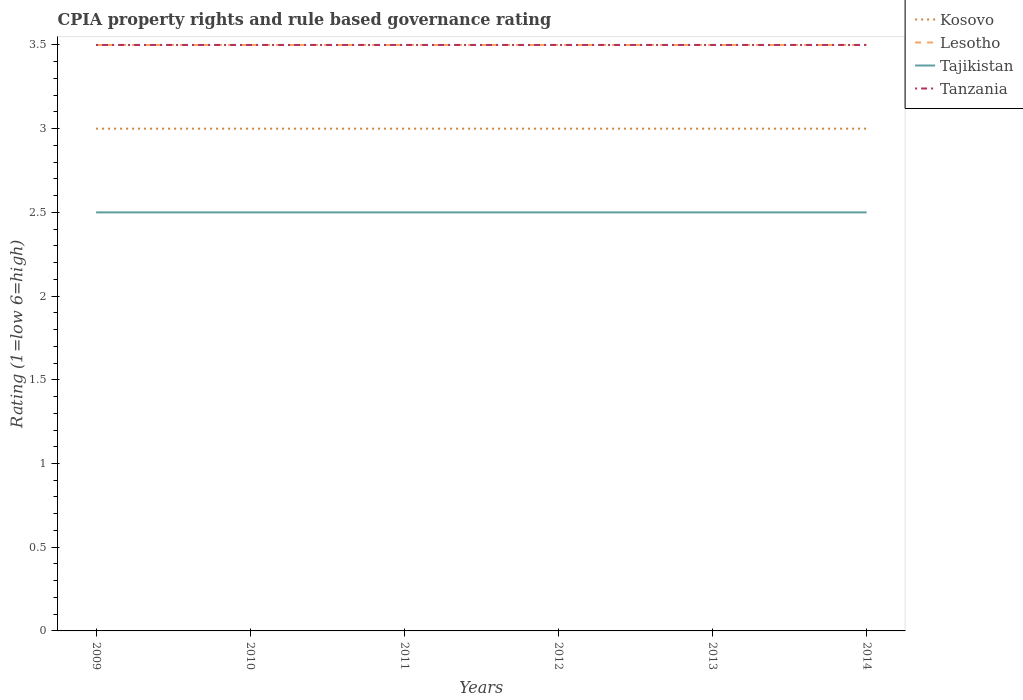Is the CPIA rating in Tajikistan strictly greater than the CPIA rating in Tanzania over the years?
Give a very brief answer. Yes. How many years are there in the graph?
Your response must be concise. 6. What is the difference between two consecutive major ticks on the Y-axis?
Your answer should be very brief. 0.5. Where does the legend appear in the graph?
Provide a succinct answer. Top right. What is the title of the graph?
Your answer should be compact. CPIA property rights and rule based governance rating. Does "Dominica" appear as one of the legend labels in the graph?
Give a very brief answer. No. What is the label or title of the Y-axis?
Make the answer very short. Rating (1=low 6=high). What is the Rating (1=low 6=high) of Kosovo in 2009?
Ensure brevity in your answer.  3. What is the Rating (1=low 6=high) of Lesotho in 2009?
Offer a terse response. 3.5. What is the Rating (1=low 6=high) of Tajikistan in 2010?
Keep it short and to the point. 2.5. What is the Rating (1=low 6=high) in Lesotho in 2011?
Provide a short and direct response. 3.5. What is the Rating (1=low 6=high) in Lesotho in 2012?
Keep it short and to the point. 3.5. What is the Rating (1=low 6=high) in Tajikistan in 2012?
Keep it short and to the point. 2.5. What is the Rating (1=low 6=high) in Tanzania in 2012?
Give a very brief answer. 3.5. What is the Rating (1=low 6=high) of Kosovo in 2013?
Give a very brief answer. 3. What is the Rating (1=low 6=high) of Tajikistan in 2013?
Keep it short and to the point. 2.5. What is the Rating (1=low 6=high) in Lesotho in 2014?
Give a very brief answer. 3.5. Across all years, what is the maximum Rating (1=low 6=high) of Kosovo?
Provide a short and direct response. 3. Across all years, what is the maximum Rating (1=low 6=high) in Tanzania?
Offer a very short reply. 3.5. Across all years, what is the minimum Rating (1=low 6=high) of Tanzania?
Offer a very short reply. 3.5. What is the total Rating (1=low 6=high) in Kosovo in the graph?
Ensure brevity in your answer.  18. What is the total Rating (1=low 6=high) of Tajikistan in the graph?
Your response must be concise. 15. What is the total Rating (1=low 6=high) in Tanzania in the graph?
Provide a succinct answer. 21. What is the difference between the Rating (1=low 6=high) in Kosovo in 2009 and that in 2010?
Provide a succinct answer. 0. What is the difference between the Rating (1=low 6=high) in Lesotho in 2009 and that in 2010?
Provide a short and direct response. 0. What is the difference between the Rating (1=low 6=high) in Kosovo in 2009 and that in 2011?
Provide a short and direct response. 0. What is the difference between the Rating (1=low 6=high) in Tajikistan in 2009 and that in 2011?
Your answer should be compact. 0. What is the difference between the Rating (1=low 6=high) of Kosovo in 2009 and that in 2012?
Your response must be concise. 0. What is the difference between the Rating (1=low 6=high) in Kosovo in 2009 and that in 2013?
Provide a short and direct response. 0. What is the difference between the Rating (1=low 6=high) in Lesotho in 2009 and that in 2013?
Keep it short and to the point. 0. What is the difference between the Rating (1=low 6=high) of Tanzania in 2009 and that in 2013?
Your response must be concise. 0. What is the difference between the Rating (1=low 6=high) of Lesotho in 2009 and that in 2014?
Ensure brevity in your answer.  0. What is the difference between the Rating (1=low 6=high) of Tanzania in 2009 and that in 2014?
Make the answer very short. 0. What is the difference between the Rating (1=low 6=high) in Kosovo in 2010 and that in 2011?
Give a very brief answer. 0. What is the difference between the Rating (1=low 6=high) of Lesotho in 2010 and that in 2011?
Provide a short and direct response. 0. What is the difference between the Rating (1=low 6=high) of Tanzania in 2010 and that in 2011?
Make the answer very short. 0. What is the difference between the Rating (1=low 6=high) of Kosovo in 2010 and that in 2012?
Offer a terse response. 0. What is the difference between the Rating (1=low 6=high) of Lesotho in 2010 and that in 2012?
Make the answer very short. 0. What is the difference between the Rating (1=low 6=high) of Kosovo in 2010 and that in 2013?
Provide a short and direct response. 0. What is the difference between the Rating (1=low 6=high) of Lesotho in 2010 and that in 2013?
Offer a terse response. 0. What is the difference between the Rating (1=low 6=high) of Tanzania in 2010 and that in 2013?
Your response must be concise. 0. What is the difference between the Rating (1=low 6=high) in Kosovo in 2010 and that in 2014?
Your response must be concise. 0. What is the difference between the Rating (1=low 6=high) in Kosovo in 2011 and that in 2012?
Offer a terse response. 0. What is the difference between the Rating (1=low 6=high) of Kosovo in 2011 and that in 2013?
Keep it short and to the point. 0. What is the difference between the Rating (1=low 6=high) of Tajikistan in 2011 and that in 2013?
Your response must be concise. 0. What is the difference between the Rating (1=low 6=high) in Tanzania in 2011 and that in 2013?
Keep it short and to the point. 0. What is the difference between the Rating (1=low 6=high) of Tajikistan in 2011 and that in 2014?
Keep it short and to the point. 0. What is the difference between the Rating (1=low 6=high) in Tanzania in 2011 and that in 2014?
Give a very brief answer. 0. What is the difference between the Rating (1=low 6=high) of Lesotho in 2012 and that in 2013?
Offer a terse response. 0. What is the difference between the Rating (1=low 6=high) of Kosovo in 2012 and that in 2014?
Your response must be concise. 0. What is the difference between the Rating (1=low 6=high) of Tanzania in 2012 and that in 2014?
Ensure brevity in your answer.  0. What is the difference between the Rating (1=low 6=high) of Lesotho in 2013 and that in 2014?
Provide a succinct answer. 0. What is the difference between the Rating (1=low 6=high) of Kosovo in 2009 and the Rating (1=low 6=high) of Lesotho in 2010?
Your response must be concise. -0.5. What is the difference between the Rating (1=low 6=high) of Tajikistan in 2009 and the Rating (1=low 6=high) of Tanzania in 2010?
Make the answer very short. -1. What is the difference between the Rating (1=low 6=high) of Kosovo in 2009 and the Rating (1=low 6=high) of Tajikistan in 2011?
Offer a very short reply. 0.5. What is the difference between the Rating (1=low 6=high) in Kosovo in 2009 and the Rating (1=low 6=high) in Tanzania in 2011?
Ensure brevity in your answer.  -0.5. What is the difference between the Rating (1=low 6=high) in Lesotho in 2009 and the Rating (1=low 6=high) in Tajikistan in 2011?
Give a very brief answer. 1. What is the difference between the Rating (1=low 6=high) in Tajikistan in 2009 and the Rating (1=low 6=high) in Tanzania in 2011?
Ensure brevity in your answer.  -1. What is the difference between the Rating (1=low 6=high) of Tajikistan in 2009 and the Rating (1=low 6=high) of Tanzania in 2012?
Ensure brevity in your answer.  -1. What is the difference between the Rating (1=low 6=high) in Kosovo in 2009 and the Rating (1=low 6=high) in Lesotho in 2013?
Give a very brief answer. -0.5. What is the difference between the Rating (1=low 6=high) in Kosovo in 2009 and the Rating (1=low 6=high) in Tajikistan in 2013?
Offer a very short reply. 0.5. What is the difference between the Rating (1=low 6=high) of Tajikistan in 2009 and the Rating (1=low 6=high) of Tanzania in 2013?
Offer a very short reply. -1. What is the difference between the Rating (1=low 6=high) of Kosovo in 2009 and the Rating (1=low 6=high) of Lesotho in 2014?
Provide a succinct answer. -0.5. What is the difference between the Rating (1=low 6=high) of Kosovo in 2009 and the Rating (1=low 6=high) of Tajikistan in 2014?
Give a very brief answer. 0.5. What is the difference between the Rating (1=low 6=high) of Kosovo in 2009 and the Rating (1=low 6=high) of Tanzania in 2014?
Offer a terse response. -0.5. What is the difference between the Rating (1=low 6=high) in Lesotho in 2009 and the Rating (1=low 6=high) in Tajikistan in 2014?
Offer a terse response. 1. What is the difference between the Rating (1=low 6=high) of Tajikistan in 2009 and the Rating (1=low 6=high) of Tanzania in 2014?
Offer a very short reply. -1. What is the difference between the Rating (1=low 6=high) in Kosovo in 2010 and the Rating (1=low 6=high) in Tanzania in 2011?
Offer a terse response. -0.5. What is the difference between the Rating (1=low 6=high) of Lesotho in 2010 and the Rating (1=low 6=high) of Tajikistan in 2011?
Ensure brevity in your answer.  1. What is the difference between the Rating (1=low 6=high) in Tajikistan in 2010 and the Rating (1=low 6=high) in Tanzania in 2011?
Ensure brevity in your answer.  -1. What is the difference between the Rating (1=low 6=high) in Kosovo in 2010 and the Rating (1=low 6=high) in Tajikistan in 2012?
Offer a terse response. 0.5. What is the difference between the Rating (1=low 6=high) in Lesotho in 2010 and the Rating (1=low 6=high) in Tanzania in 2012?
Your answer should be compact. 0. What is the difference between the Rating (1=low 6=high) in Tajikistan in 2010 and the Rating (1=low 6=high) in Tanzania in 2012?
Ensure brevity in your answer.  -1. What is the difference between the Rating (1=low 6=high) in Kosovo in 2010 and the Rating (1=low 6=high) in Lesotho in 2013?
Ensure brevity in your answer.  -0.5. What is the difference between the Rating (1=low 6=high) of Kosovo in 2010 and the Rating (1=low 6=high) of Tajikistan in 2013?
Provide a succinct answer. 0.5. What is the difference between the Rating (1=low 6=high) in Kosovo in 2010 and the Rating (1=low 6=high) in Tanzania in 2013?
Give a very brief answer. -0.5. What is the difference between the Rating (1=low 6=high) in Lesotho in 2010 and the Rating (1=low 6=high) in Tajikistan in 2013?
Offer a terse response. 1. What is the difference between the Rating (1=low 6=high) of Lesotho in 2010 and the Rating (1=low 6=high) of Tanzania in 2013?
Make the answer very short. 0. What is the difference between the Rating (1=low 6=high) in Tajikistan in 2010 and the Rating (1=low 6=high) in Tanzania in 2013?
Give a very brief answer. -1. What is the difference between the Rating (1=low 6=high) in Kosovo in 2010 and the Rating (1=low 6=high) in Lesotho in 2014?
Keep it short and to the point. -0.5. What is the difference between the Rating (1=low 6=high) in Kosovo in 2010 and the Rating (1=low 6=high) in Tanzania in 2014?
Provide a succinct answer. -0.5. What is the difference between the Rating (1=low 6=high) in Lesotho in 2010 and the Rating (1=low 6=high) in Tajikistan in 2014?
Your response must be concise. 1. What is the difference between the Rating (1=low 6=high) of Kosovo in 2011 and the Rating (1=low 6=high) of Tajikistan in 2012?
Ensure brevity in your answer.  0.5. What is the difference between the Rating (1=low 6=high) in Kosovo in 2011 and the Rating (1=low 6=high) in Tanzania in 2012?
Your answer should be compact. -0.5. What is the difference between the Rating (1=low 6=high) of Lesotho in 2011 and the Rating (1=low 6=high) of Tanzania in 2012?
Provide a short and direct response. 0. What is the difference between the Rating (1=low 6=high) in Kosovo in 2011 and the Rating (1=low 6=high) in Tanzania in 2013?
Your answer should be compact. -0.5. What is the difference between the Rating (1=low 6=high) in Lesotho in 2011 and the Rating (1=low 6=high) in Tajikistan in 2013?
Ensure brevity in your answer.  1. What is the difference between the Rating (1=low 6=high) of Lesotho in 2011 and the Rating (1=low 6=high) of Tanzania in 2013?
Provide a short and direct response. 0. What is the difference between the Rating (1=low 6=high) in Tajikistan in 2011 and the Rating (1=low 6=high) in Tanzania in 2013?
Give a very brief answer. -1. What is the difference between the Rating (1=low 6=high) of Lesotho in 2011 and the Rating (1=low 6=high) of Tajikistan in 2014?
Ensure brevity in your answer.  1. What is the difference between the Rating (1=low 6=high) of Lesotho in 2011 and the Rating (1=low 6=high) of Tanzania in 2014?
Your answer should be compact. 0. What is the difference between the Rating (1=low 6=high) of Tajikistan in 2011 and the Rating (1=low 6=high) of Tanzania in 2014?
Make the answer very short. -1. What is the difference between the Rating (1=low 6=high) of Kosovo in 2012 and the Rating (1=low 6=high) of Tanzania in 2013?
Ensure brevity in your answer.  -0.5. What is the difference between the Rating (1=low 6=high) in Lesotho in 2012 and the Rating (1=low 6=high) in Tanzania in 2013?
Make the answer very short. 0. What is the difference between the Rating (1=low 6=high) of Kosovo in 2012 and the Rating (1=low 6=high) of Tajikistan in 2014?
Your answer should be compact. 0.5. What is the difference between the Rating (1=low 6=high) in Lesotho in 2012 and the Rating (1=low 6=high) in Tajikistan in 2014?
Make the answer very short. 1. What is the difference between the Rating (1=low 6=high) in Lesotho in 2012 and the Rating (1=low 6=high) in Tanzania in 2014?
Offer a terse response. 0. What is the difference between the Rating (1=low 6=high) of Tajikistan in 2012 and the Rating (1=low 6=high) of Tanzania in 2014?
Your response must be concise. -1. What is the difference between the Rating (1=low 6=high) of Kosovo in 2013 and the Rating (1=low 6=high) of Tanzania in 2014?
Ensure brevity in your answer.  -0.5. What is the difference between the Rating (1=low 6=high) in Lesotho in 2013 and the Rating (1=low 6=high) in Tajikistan in 2014?
Make the answer very short. 1. In the year 2009, what is the difference between the Rating (1=low 6=high) of Kosovo and Rating (1=low 6=high) of Lesotho?
Your answer should be very brief. -0.5. In the year 2009, what is the difference between the Rating (1=low 6=high) in Lesotho and Rating (1=low 6=high) in Tanzania?
Your answer should be compact. 0. In the year 2009, what is the difference between the Rating (1=low 6=high) of Tajikistan and Rating (1=low 6=high) of Tanzania?
Your response must be concise. -1. In the year 2010, what is the difference between the Rating (1=low 6=high) in Kosovo and Rating (1=low 6=high) in Lesotho?
Offer a very short reply. -0.5. In the year 2010, what is the difference between the Rating (1=low 6=high) in Kosovo and Rating (1=low 6=high) in Tanzania?
Your answer should be very brief. -0.5. In the year 2010, what is the difference between the Rating (1=low 6=high) in Lesotho and Rating (1=low 6=high) in Tajikistan?
Make the answer very short. 1. In the year 2010, what is the difference between the Rating (1=low 6=high) in Tajikistan and Rating (1=low 6=high) in Tanzania?
Offer a terse response. -1. In the year 2011, what is the difference between the Rating (1=low 6=high) of Kosovo and Rating (1=low 6=high) of Tajikistan?
Your answer should be compact. 0.5. In the year 2011, what is the difference between the Rating (1=low 6=high) of Kosovo and Rating (1=low 6=high) of Tanzania?
Offer a terse response. -0.5. In the year 2011, what is the difference between the Rating (1=low 6=high) of Lesotho and Rating (1=low 6=high) of Tajikistan?
Give a very brief answer. 1. In the year 2011, what is the difference between the Rating (1=low 6=high) of Tajikistan and Rating (1=low 6=high) of Tanzania?
Provide a short and direct response. -1. In the year 2012, what is the difference between the Rating (1=low 6=high) of Tajikistan and Rating (1=low 6=high) of Tanzania?
Your answer should be compact. -1. In the year 2013, what is the difference between the Rating (1=low 6=high) of Lesotho and Rating (1=low 6=high) of Tajikistan?
Your answer should be compact. 1. In the year 2013, what is the difference between the Rating (1=low 6=high) in Lesotho and Rating (1=low 6=high) in Tanzania?
Your answer should be compact. 0. In the year 2013, what is the difference between the Rating (1=low 6=high) in Tajikistan and Rating (1=low 6=high) in Tanzania?
Offer a terse response. -1. In the year 2014, what is the difference between the Rating (1=low 6=high) of Kosovo and Rating (1=low 6=high) of Tajikistan?
Offer a terse response. 0.5. In the year 2014, what is the difference between the Rating (1=low 6=high) of Kosovo and Rating (1=low 6=high) of Tanzania?
Your answer should be compact. -0.5. In the year 2014, what is the difference between the Rating (1=low 6=high) in Lesotho and Rating (1=low 6=high) in Tajikistan?
Your response must be concise. 1. What is the ratio of the Rating (1=low 6=high) in Kosovo in 2009 to that in 2010?
Your response must be concise. 1. What is the ratio of the Rating (1=low 6=high) of Kosovo in 2009 to that in 2011?
Provide a succinct answer. 1. What is the ratio of the Rating (1=low 6=high) in Lesotho in 2009 to that in 2011?
Give a very brief answer. 1. What is the ratio of the Rating (1=low 6=high) in Tajikistan in 2009 to that in 2011?
Keep it short and to the point. 1. What is the ratio of the Rating (1=low 6=high) of Tanzania in 2009 to that in 2011?
Offer a very short reply. 1. What is the ratio of the Rating (1=low 6=high) in Tajikistan in 2009 to that in 2012?
Give a very brief answer. 1. What is the ratio of the Rating (1=low 6=high) in Lesotho in 2009 to that in 2013?
Make the answer very short. 1. What is the ratio of the Rating (1=low 6=high) of Tanzania in 2009 to that in 2013?
Provide a succinct answer. 1. What is the ratio of the Rating (1=low 6=high) in Kosovo in 2009 to that in 2014?
Provide a succinct answer. 1. What is the ratio of the Rating (1=low 6=high) of Lesotho in 2009 to that in 2014?
Your response must be concise. 1. What is the ratio of the Rating (1=low 6=high) in Lesotho in 2010 to that in 2011?
Give a very brief answer. 1. What is the ratio of the Rating (1=low 6=high) in Lesotho in 2010 to that in 2012?
Make the answer very short. 1. What is the ratio of the Rating (1=low 6=high) of Tajikistan in 2010 to that in 2012?
Ensure brevity in your answer.  1. What is the ratio of the Rating (1=low 6=high) of Lesotho in 2010 to that in 2013?
Ensure brevity in your answer.  1. What is the ratio of the Rating (1=low 6=high) of Tajikistan in 2010 to that in 2013?
Provide a short and direct response. 1. What is the ratio of the Rating (1=low 6=high) of Kosovo in 2010 to that in 2014?
Give a very brief answer. 1. What is the ratio of the Rating (1=low 6=high) in Tanzania in 2010 to that in 2014?
Your answer should be compact. 1. What is the ratio of the Rating (1=low 6=high) in Lesotho in 2011 to that in 2013?
Offer a very short reply. 1. What is the ratio of the Rating (1=low 6=high) of Tajikistan in 2011 to that in 2013?
Ensure brevity in your answer.  1. What is the ratio of the Rating (1=low 6=high) in Kosovo in 2011 to that in 2014?
Keep it short and to the point. 1. What is the ratio of the Rating (1=low 6=high) in Tanzania in 2011 to that in 2014?
Keep it short and to the point. 1. What is the ratio of the Rating (1=low 6=high) in Kosovo in 2012 to that in 2013?
Provide a succinct answer. 1. What is the ratio of the Rating (1=low 6=high) in Lesotho in 2012 to that in 2013?
Offer a terse response. 1. What is the ratio of the Rating (1=low 6=high) of Lesotho in 2012 to that in 2014?
Offer a very short reply. 1. What is the ratio of the Rating (1=low 6=high) of Tajikistan in 2012 to that in 2014?
Ensure brevity in your answer.  1. What is the ratio of the Rating (1=low 6=high) in Tanzania in 2012 to that in 2014?
Ensure brevity in your answer.  1. What is the ratio of the Rating (1=low 6=high) in Kosovo in 2013 to that in 2014?
Keep it short and to the point. 1. What is the ratio of the Rating (1=low 6=high) of Tajikistan in 2013 to that in 2014?
Ensure brevity in your answer.  1. What is the difference between the highest and the second highest Rating (1=low 6=high) of Lesotho?
Ensure brevity in your answer.  0. What is the difference between the highest and the second highest Rating (1=low 6=high) of Tajikistan?
Your answer should be compact. 0. What is the difference between the highest and the second highest Rating (1=low 6=high) in Tanzania?
Give a very brief answer. 0. What is the difference between the highest and the lowest Rating (1=low 6=high) in Lesotho?
Your answer should be very brief. 0. 